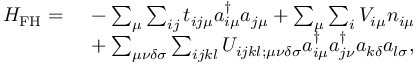Convert formula to latex. <formula><loc_0><loc_0><loc_500><loc_500>\begin{array} { r l } { H _ { F H } = \, } & - \sum _ { \mu } \sum _ { i j } t _ { i j \mu } a _ { i \mu } ^ { \dagger } a _ { j \mu } + \sum _ { \mu } \sum _ { i } V _ { i \mu } n _ { i \mu } } \\ { \, } & + \sum _ { \mu \nu \delta \sigma } \sum _ { i j k l } U _ { i j k l ; \mu \nu \delta \sigma } a _ { i \mu } ^ { \dagger } a _ { j \nu } ^ { \dagger } a _ { k \delta } a _ { l \sigma } , } \end{array}</formula> 